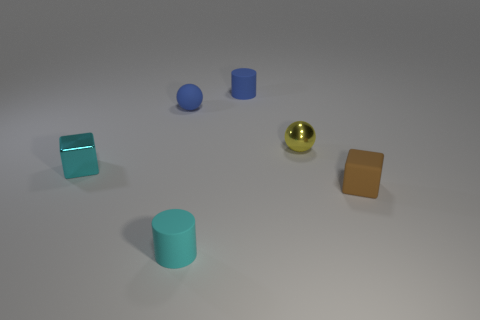Add 2 cyan matte things. How many objects exist? 8 Subtract all cylinders. How many objects are left? 4 Add 2 balls. How many balls exist? 4 Subtract 0 purple balls. How many objects are left? 6 Subtract all small objects. Subtract all metal cylinders. How many objects are left? 0 Add 2 blue rubber balls. How many blue rubber balls are left? 3 